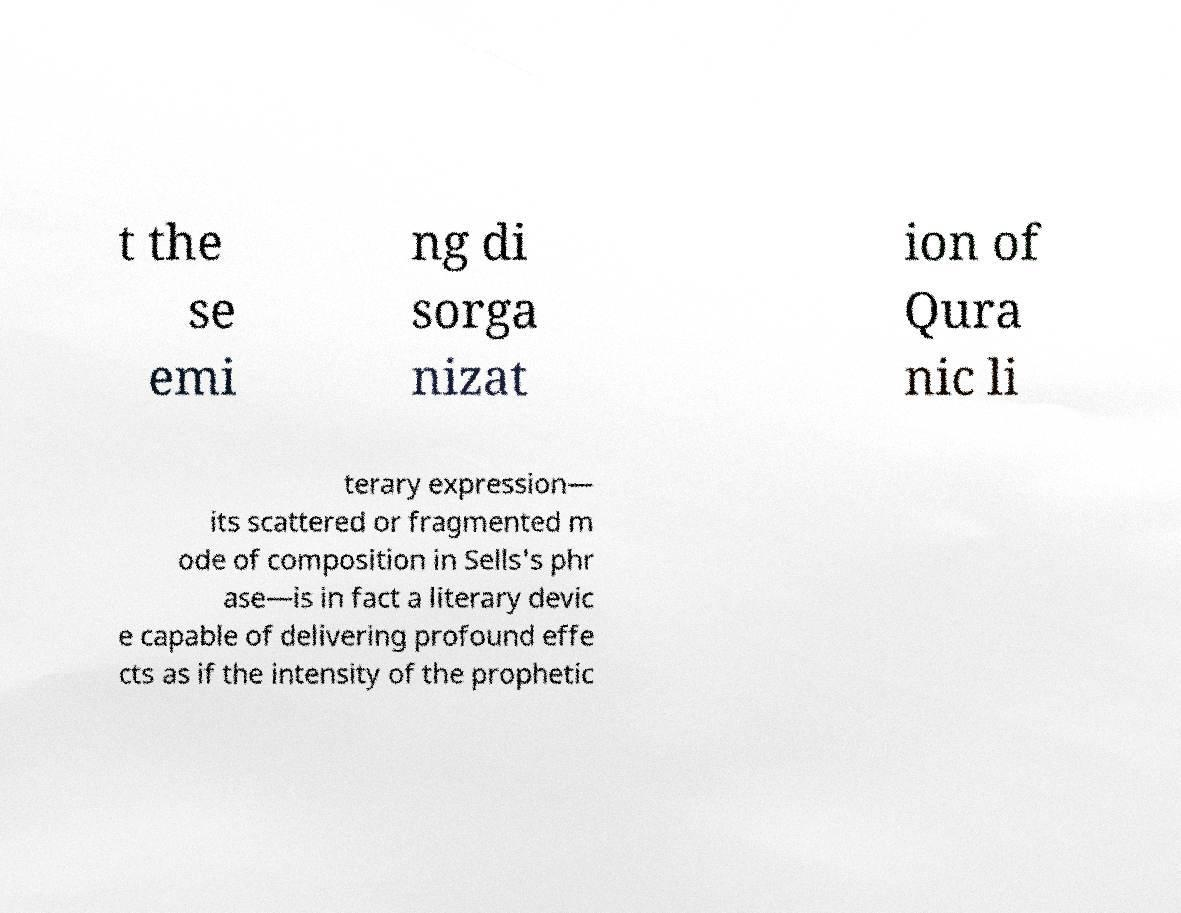For documentation purposes, I need the text within this image transcribed. Could you provide that? t the se emi ng di sorga nizat ion of Qura nic li terary expression— its scattered or fragmented m ode of composition in Sells's phr ase—is in fact a literary devic e capable of delivering profound effe cts as if the intensity of the prophetic 